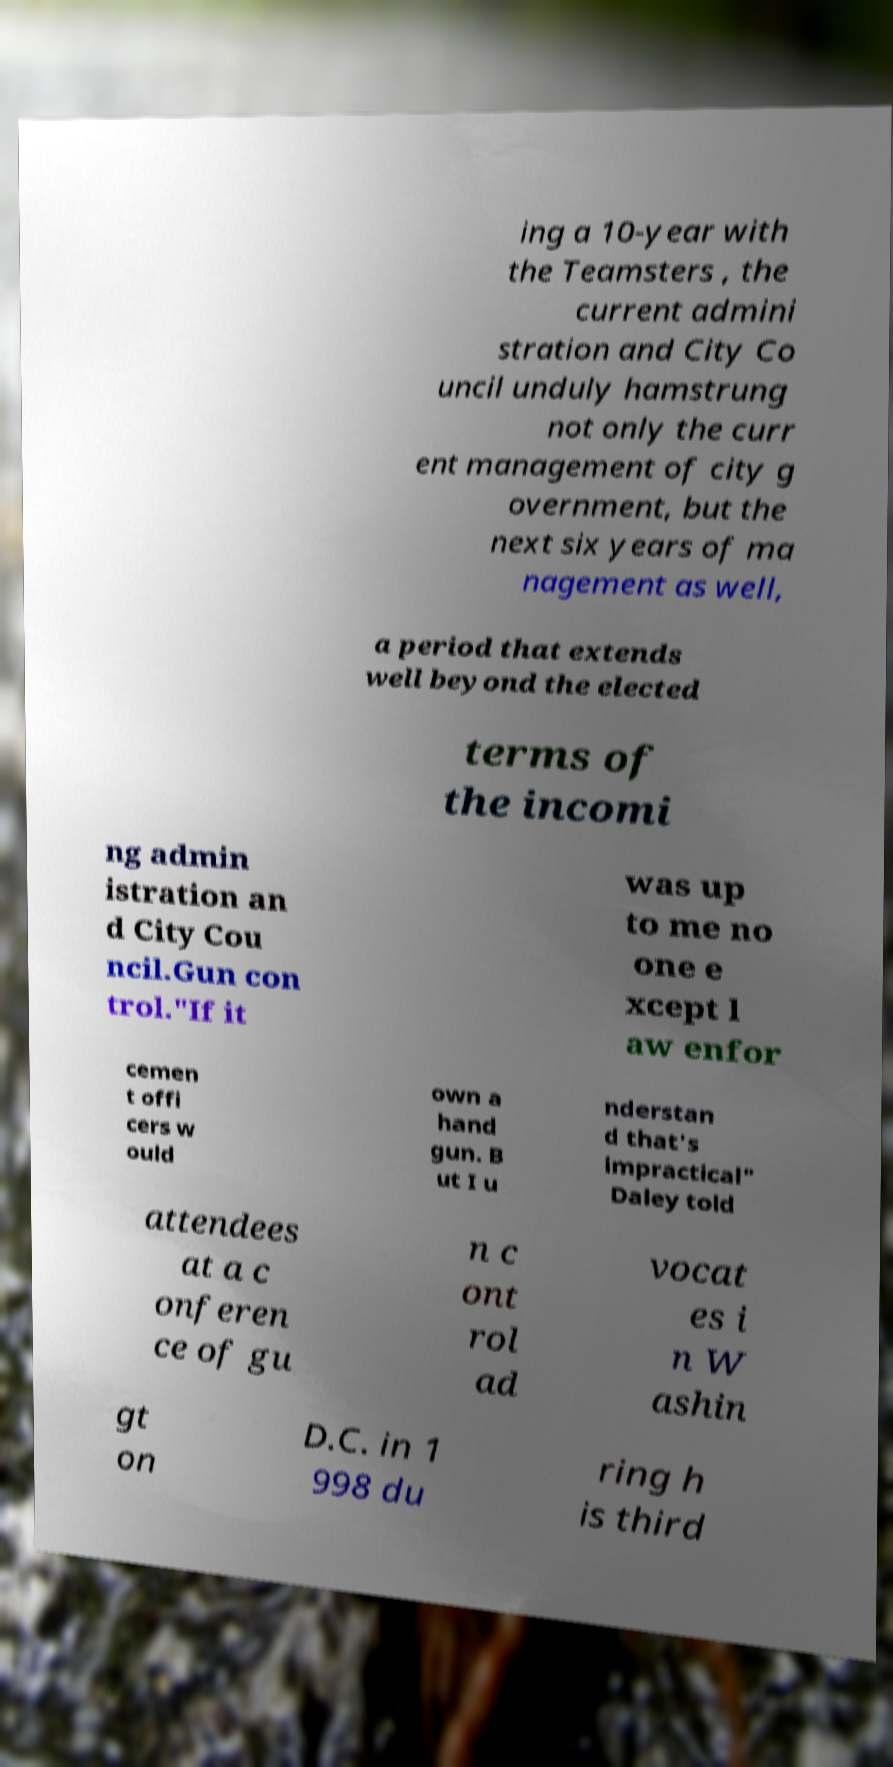Please identify and transcribe the text found in this image. ing a 10-year with the Teamsters , the current admini stration and City Co uncil unduly hamstrung not only the curr ent management of city g overnment, but the next six years of ma nagement as well, a period that extends well beyond the elected terms of the incomi ng admin istration an d City Cou ncil.Gun con trol."If it was up to me no one e xcept l aw enfor cemen t offi cers w ould own a hand gun. B ut I u nderstan d that's impractical" Daley told attendees at a c onferen ce of gu n c ont rol ad vocat es i n W ashin gt on D.C. in 1 998 du ring h is third 